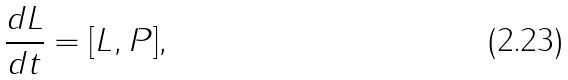Convert formula to latex. <formula><loc_0><loc_0><loc_500><loc_500>\frac { d L } { d t } = [ L , P ] ,</formula> 